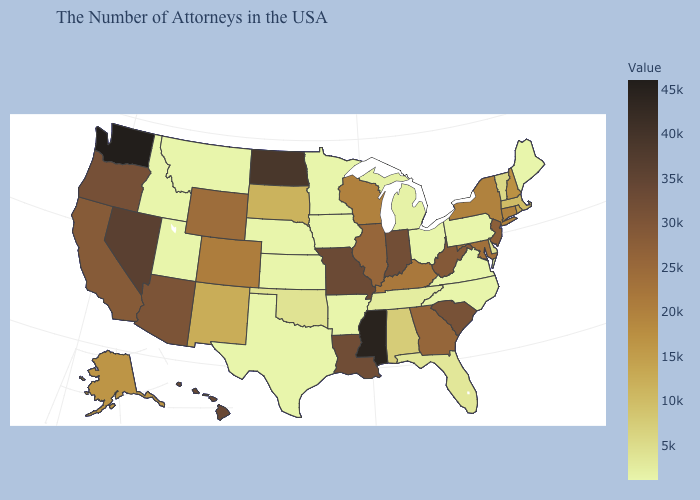Which states have the lowest value in the USA?
Quick response, please. Maine, Pennsylvania, Virginia, North Carolina, Ohio, Arkansas, Minnesota, Iowa, Kansas, Nebraska, Texas, Utah, Montana, Idaho. Which states hav the highest value in the South?
Answer briefly. Mississippi. Is the legend a continuous bar?
Short answer required. Yes. 